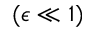Convert formula to latex. <formula><loc_0><loc_0><loc_500><loc_500>( \epsilon \ll 1 )</formula> 